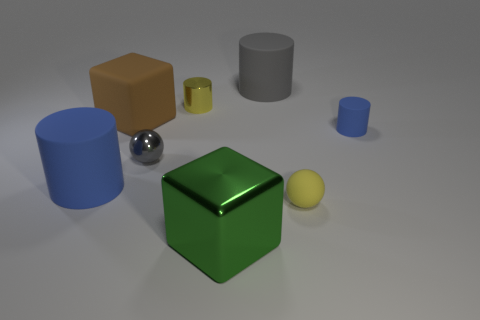Are there fewer small yellow metal things in front of the small gray shiny ball than small gray metal cubes?
Your response must be concise. No. There is a tiny yellow object on the left side of the gray cylinder; is it the same shape as the tiny gray metal thing that is behind the large metal cube?
Ensure brevity in your answer.  No. How many things are either large rubber things that are on the right side of the big matte cube or large gray metallic cylinders?
Offer a very short reply. 1. There is a cylinder that is the same color as the small matte sphere; what material is it?
Ensure brevity in your answer.  Metal. There is a big cylinder that is behind the matte cylinder that is left of the shiny block; are there any cylinders that are in front of it?
Your response must be concise. Yes. Is the number of green shiny blocks that are on the left side of the large brown matte block less than the number of small yellow things behind the big blue rubber cylinder?
Give a very brief answer. Yes. There is a tiny sphere that is made of the same material as the big gray object; what color is it?
Give a very brief answer. Yellow. There is a large cylinder that is left of the cube that is left of the large green thing; what color is it?
Your answer should be very brief. Blue. Is there a rubber thing that has the same color as the tiny metal ball?
Your response must be concise. Yes. There is a brown object that is the same size as the green metallic thing; what shape is it?
Your response must be concise. Cube. 